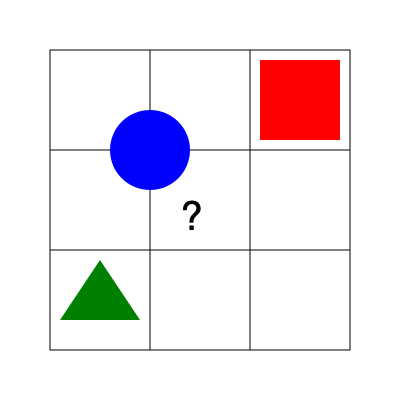Analyze the given 3x3 grid diagram. Each cell contains a different geometric shape, except for one cell marked with a question mark. Based on the pattern, what shape should replace the question mark? To solve this puzzle, we need to analyze the pattern in the given 3x3 grid:

1. Observe the shapes in each cell:
   - Top left: Blue circle
   - Top middle: Empty
   - Top right: Red square
   - Middle left: Empty
   - Middle center: Question mark
   - Middle right: Empty
   - Bottom left: Green triangle
   - Bottom middle: Empty
   - Bottom right: Empty

2. Notice that the shapes are positioned in the corners of the grid:
   - Circle in top-left
   - Square in top-right
   - Triangle in bottom-left

3. Identify the pattern:
   - The shapes are primary colors: blue, red, and green
   - They are basic geometric shapes: circle, square, and triangle
   - They are placed in a clockwise direction: top-left, top-right, bottom-left

4. Determine the missing shape:
   - To complete the pattern, we need a shape in the bottom-right corner
   - Following the clockwise direction, the next shape should be in the bottom-right
   - The missing shape should be different from the existing ones

5. Conclude:
   - The missing shape should be a yellow diamond (rhombus)
   - This completes the pattern of primary colors and basic shapes in a clockwise direction
Answer: Yellow diamond (rhombus) 